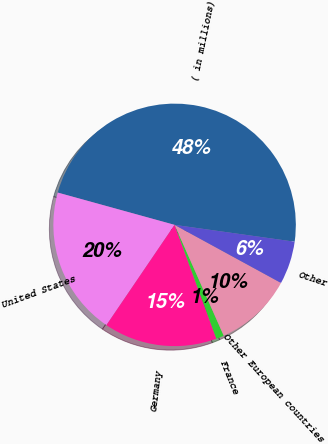Convert chart. <chart><loc_0><loc_0><loc_500><loc_500><pie_chart><fcel>( in millions)<fcel>United States<fcel>Germany<fcel>France<fcel>Other European countries<fcel>Other<nl><fcel>47.93%<fcel>19.79%<fcel>15.1%<fcel>1.04%<fcel>10.41%<fcel>5.73%<nl></chart> 